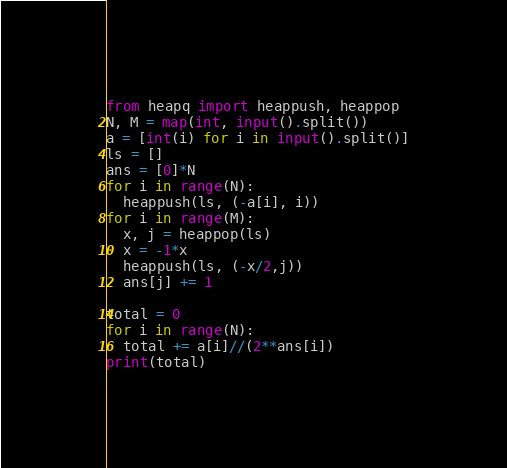Convert code to text. <code><loc_0><loc_0><loc_500><loc_500><_Python_>from heapq import heappush, heappop
N, M = map(int, input().split())
a = [int(i) for i in input().split()]
ls = []
ans = [0]*N
for i in range(N):
  heappush(ls, (-a[i], i))
for i in range(M):
  x, j = heappop(ls)
  x = -1*x
  heappush(ls, (-x/2,j))
  ans[j] += 1

total = 0
for i in range(N):
  total += a[i]//(2**ans[i])
print(total)</code> 